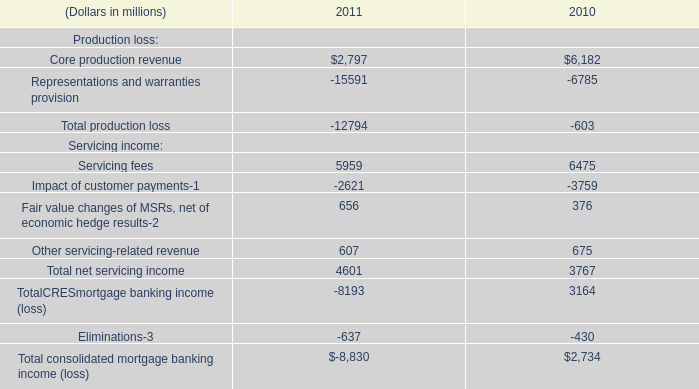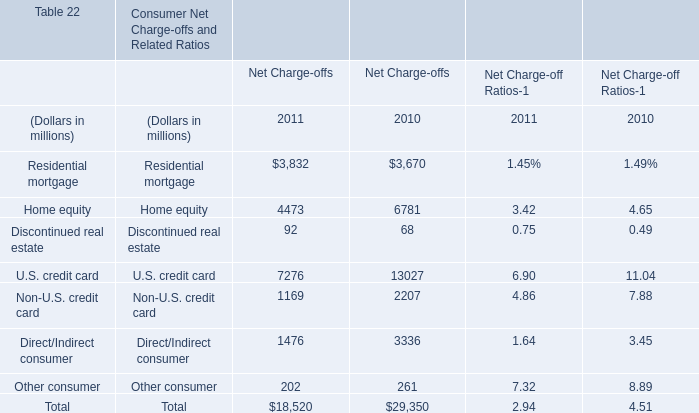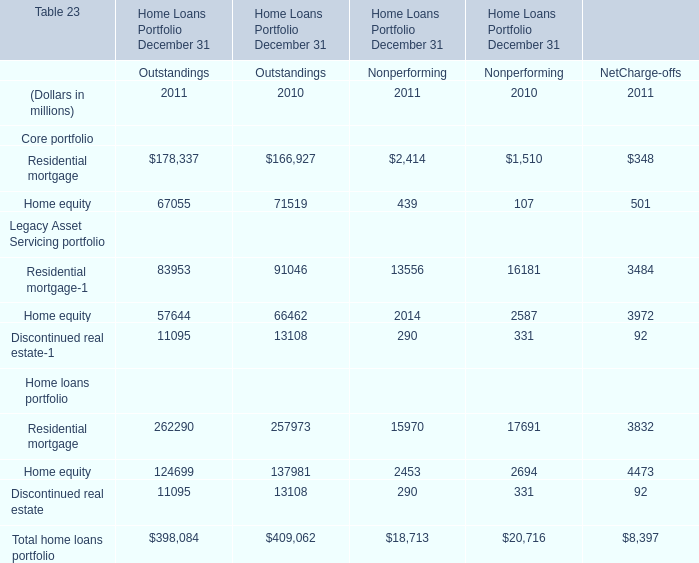Which year is Residential mortgage the highest for Net Charge-offs? 
Answer: 2011. 